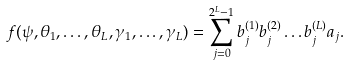Convert formula to latex. <formula><loc_0><loc_0><loc_500><loc_500>f ( \psi , \theta _ { 1 } , \dots , \theta _ { L } , \gamma _ { 1 } , \dots , \gamma _ { L } ) = \sum _ { j = 0 } ^ { 2 ^ { L } - 1 } b _ { j } ^ { ( 1 ) } b _ { j } ^ { ( 2 ) } \dots b _ { j } ^ { ( L ) } a _ { j } .</formula> 